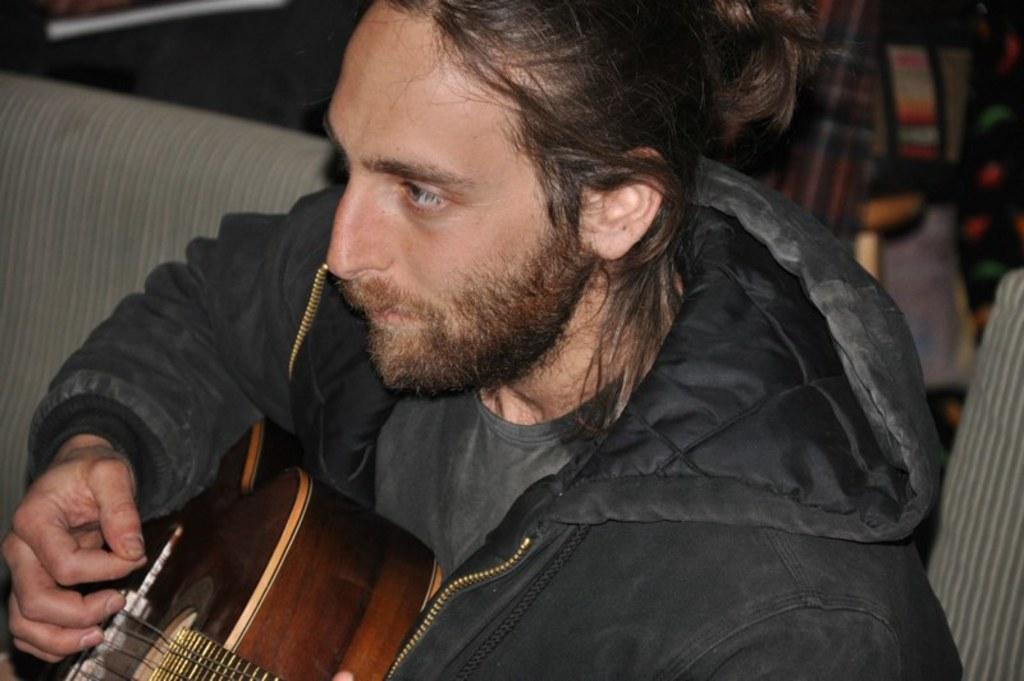What is the main subject of the image? The main subject of the image is a person. What is the person wearing in the image? The person is wearing a black color jacket. What activity is the person engaged in? The person is playing a guitar. What type of silk fabric is visible in the image? There is no silk fabric present in the image. What street is the person playing the guitar on during their vacation? The image does not provide information about the person's location or whether they are on vacation. 